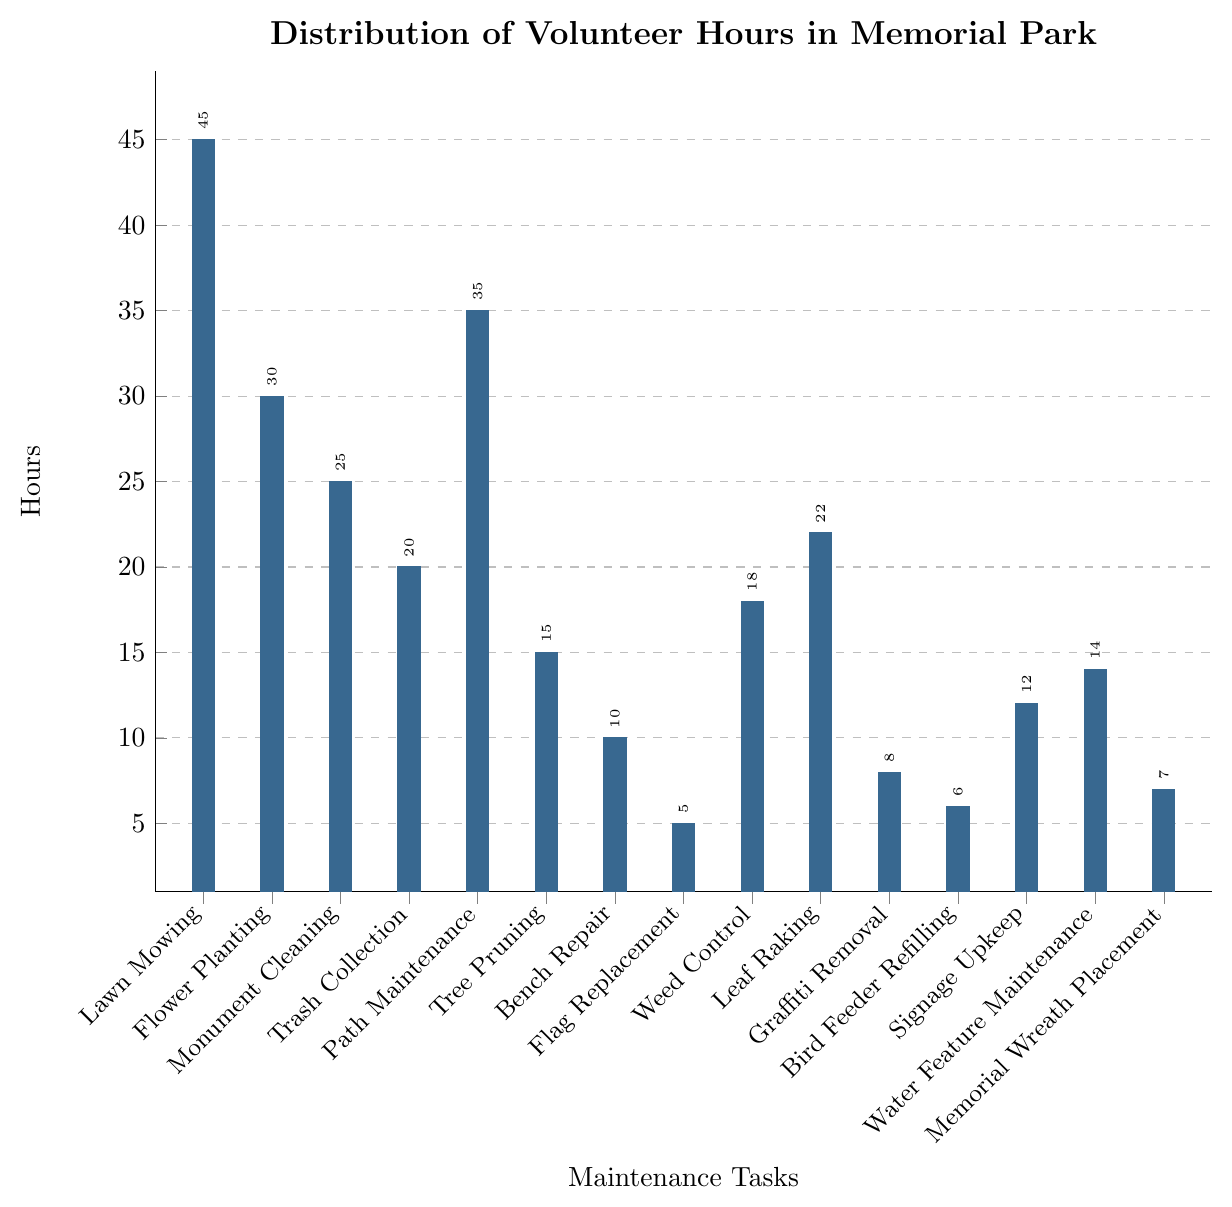Which maintenance task had the highest number of volunteer hours? Look for the tallest bar in the chart, which corresponds to the maintenance task with the highest number of hours.
Answer: Lawn Mowing Which maintenance task had the least number of volunteer hours? Look for the shortest bar in the chart, which corresponds to the maintenance task with the least number of hours.
Answer: Flag Replacement How many more hours were spent on Lawn Mowing compared to Tree Pruning? Find the bar heights for both tasks. Subtract the height of the Tree Pruning bar (15) from the height of the Lawn Mowing bar (45).
Answer: 30 How does the time spent on Path Maintenance compare to the time spent on Weed Control and Leaf Raking combined? Find the bar heights for Path Maintenance (35), Weed Control (18), and Leaf Raking (22). Add the hours of Weed Control and Leaf Raking (18 + 22 = 40) and compare this sum to Path Maintenance (35).
Answer: Less Which activity took more hours: Monument Cleaning or Leaf Raking? Compare the heights of the bars for Monument Cleaning (25) and Leaf Raking (22).
Answer: Monument Cleaning What is the total number of volunteer hours spent on Trash Collection, Bench Repair, and Graffiti Removal? Find the bar heights for Trash Collection (20), Bench Repair (10), and Graffiti Removal (8). Sum these values (20 + 10 + 8).
Answer: 38 Is the number of hours spent on Water Feature Maintenance more or less than the hours spent on Bird Feeder Refilling and Flag Replacement combined? Find the bar heights for Water Feature Maintenance (14), Bird Feeder Refilling (6), and Flag Replacement (5). Sum the hours for Bird Feeder Refilling and Flag Replacement (6 + 5 = 11) and compare this sum to Water Feature Maintenance (14).
Answer: More What's the average number of volunteer hours spent across all the maintenance tasks shown in the chart? Sum all the task hours: 45 + 30 + 25 + 20 + 35 + 15 + 10 + 5 + 18 + 22 + 8 + 6 + 12 + 14 + 7 = 272. Divide by the number of tasks (15).
Answer: 18.13 